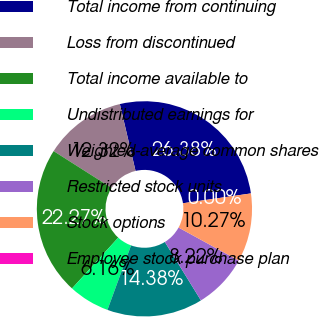Convert chart. <chart><loc_0><loc_0><loc_500><loc_500><pie_chart><fcel>Total income from continuing<fcel>Loss from discontinued<fcel>Total income available to<fcel>Undistributed earnings for<fcel>Weighted-average common shares<fcel>Restricted stock units<fcel>Stock options<fcel>Employee stock purchase plan<nl><fcel>26.38%<fcel>12.32%<fcel>22.27%<fcel>6.16%<fcel>14.38%<fcel>8.22%<fcel>10.27%<fcel>0.0%<nl></chart> 